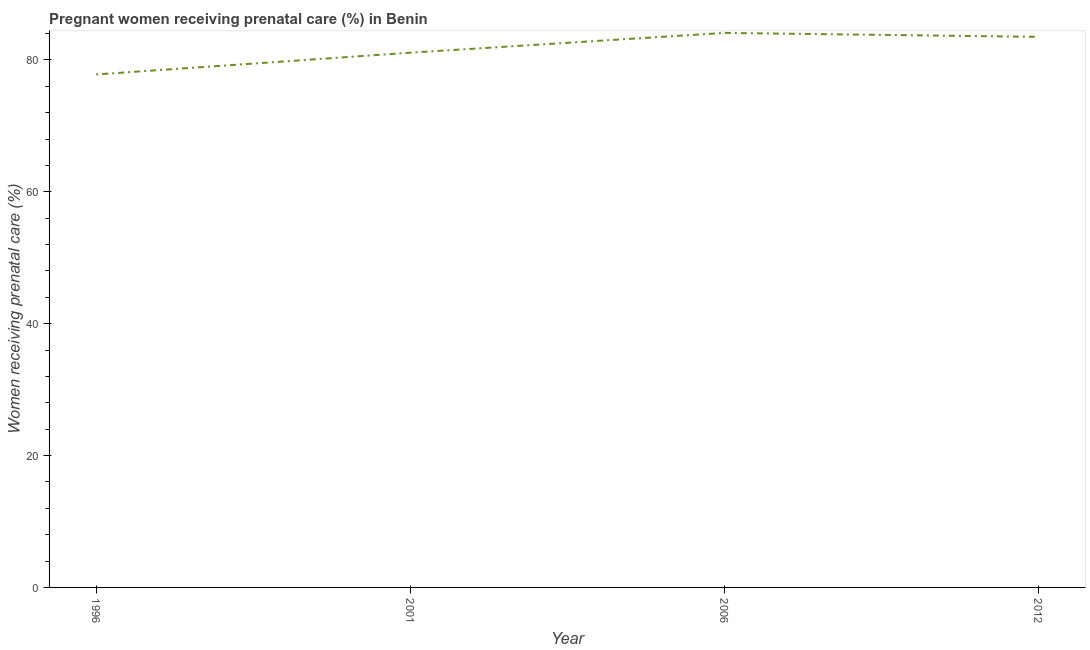What is the percentage of pregnant women receiving prenatal care in 2006?
Provide a short and direct response. 84.1. Across all years, what is the maximum percentage of pregnant women receiving prenatal care?
Your answer should be compact. 84.1. Across all years, what is the minimum percentage of pregnant women receiving prenatal care?
Provide a succinct answer. 77.8. In which year was the percentage of pregnant women receiving prenatal care maximum?
Ensure brevity in your answer.  2006. What is the sum of the percentage of pregnant women receiving prenatal care?
Your response must be concise. 326.5. What is the difference between the percentage of pregnant women receiving prenatal care in 2006 and 2012?
Offer a terse response. 0.6. What is the average percentage of pregnant women receiving prenatal care per year?
Give a very brief answer. 81.62. What is the median percentage of pregnant women receiving prenatal care?
Offer a terse response. 82.3. In how many years, is the percentage of pregnant women receiving prenatal care greater than 32 %?
Your response must be concise. 4. Do a majority of the years between 1996 and 2012 (inclusive) have percentage of pregnant women receiving prenatal care greater than 4 %?
Ensure brevity in your answer.  Yes. What is the ratio of the percentage of pregnant women receiving prenatal care in 2006 to that in 2012?
Your answer should be compact. 1.01. Is the percentage of pregnant women receiving prenatal care in 1996 less than that in 2001?
Make the answer very short. Yes. Is the difference between the percentage of pregnant women receiving prenatal care in 2006 and 2012 greater than the difference between any two years?
Your answer should be very brief. No. What is the difference between the highest and the second highest percentage of pregnant women receiving prenatal care?
Offer a terse response. 0.6. What is the difference between the highest and the lowest percentage of pregnant women receiving prenatal care?
Keep it short and to the point. 6.3. Does the percentage of pregnant women receiving prenatal care monotonically increase over the years?
Provide a short and direct response. No. How many years are there in the graph?
Your response must be concise. 4. What is the difference between two consecutive major ticks on the Y-axis?
Make the answer very short. 20. Does the graph contain grids?
Your response must be concise. No. What is the title of the graph?
Your answer should be very brief. Pregnant women receiving prenatal care (%) in Benin. What is the label or title of the Y-axis?
Keep it short and to the point. Women receiving prenatal care (%). What is the Women receiving prenatal care (%) of 1996?
Keep it short and to the point. 77.8. What is the Women receiving prenatal care (%) in 2001?
Your response must be concise. 81.1. What is the Women receiving prenatal care (%) in 2006?
Give a very brief answer. 84.1. What is the Women receiving prenatal care (%) in 2012?
Give a very brief answer. 83.5. What is the difference between the Women receiving prenatal care (%) in 2001 and 2012?
Provide a short and direct response. -2.4. What is the difference between the Women receiving prenatal care (%) in 2006 and 2012?
Make the answer very short. 0.6. What is the ratio of the Women receiving prenatal care (%) in 1996 to that in 2006?
Your answer should be very brief. 0.93. What is the ratio of the Women receiving prenatal care (%) in 1996 to that in 2012?
Make the answer very short. 0.93. What is the ratio of the Women receiving prenatal care (%) in 2006 to that in 2012?
Ensure brevity in your answer.  1.01. 